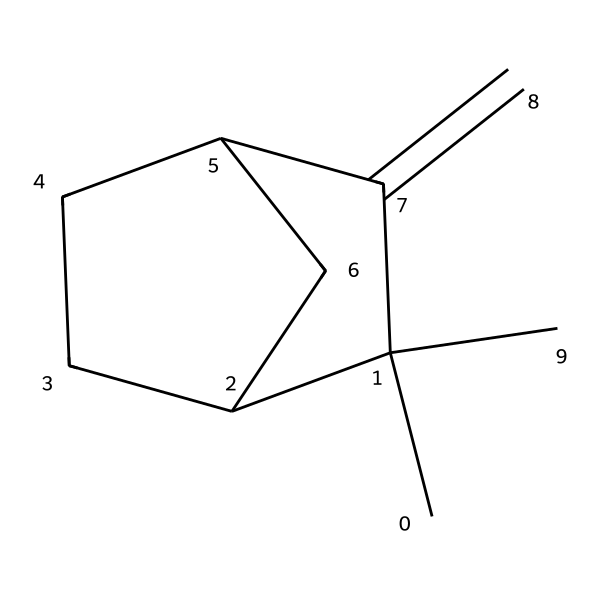What is the molecular formula of camphene? Analyzing the SMILES representation, we can count the number of carbon (C) and hydrogen (H) atoms. In this structure, there are 10 carbon atoms and 16 hydrogen atoms, leading to the molecular formula C10H16.
Answer: C10H16 How many rings are present in the structure of camphene? The structure shows a bicyclic arrangement, which contains two interconnected ring structures based on the points in the SMILES notation indicating closed loops. Therefore, there are 2 rings present.
Answer: 2 What type of hydrocarbon is camphene classified as? Camphene contains only carbon and hydrogen atoms and has multiple double bonds, indicating that it falls into the category of unsaturated hydrocarbons, specifically classified as a terpene.
Answer: terpene What is the degree of unsaturation in camphene? The degree of unsaturation can be calculated from the formula: (2C + 2 - H)/2. For camphene (C10H16), the calculation is (2(10) + 2 - 16)/2 = 3. This indicates that there are 3 pi bonds or rings in the structure.
Answer: 3 Does camphene have a branched structure? Upon examining the structure, it’s evident that there are side chains branching off the main ring systems. This confirms that camphene does indeed have a branched structure.
Answer: yes 